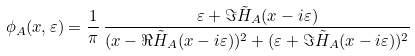Convert formula to latex. <formula><loc_0><loc_0><loc_500><loc_500>\phi _ { A } ( x , \varepsilon ) = \frac { 1 } { \pi } \, \frac { \varepsilon + \Im \tilde { H } _ { A } ( x - i \varepsilon ) } { ( x - \Re \tilde { H } _ { A } ( x - i \varepsilon ) ) ^ { 2 } + ( \varepsilon + \Im \tilde { H } _ { A } ( x - i \varepsilon ) ) ^ { 2 } }</formula> 